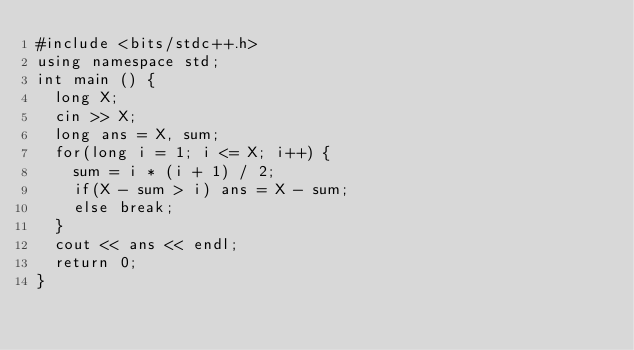<code> <loc_0><loc_0><loc_500><loc_500><_C++_>#include <bits/stdc++.h>
using namespace std;
int main () {
  long X;
  cin >> X;
  long ans = X, sum;
  for(long i = 1; i <= X; i++) {
    sum = i * (i + 1) / 2;
    if(X - sum > i) ans = X - sum;
    else break;
  }
  cout << ans << endl;
  return 0;
}
</code> 